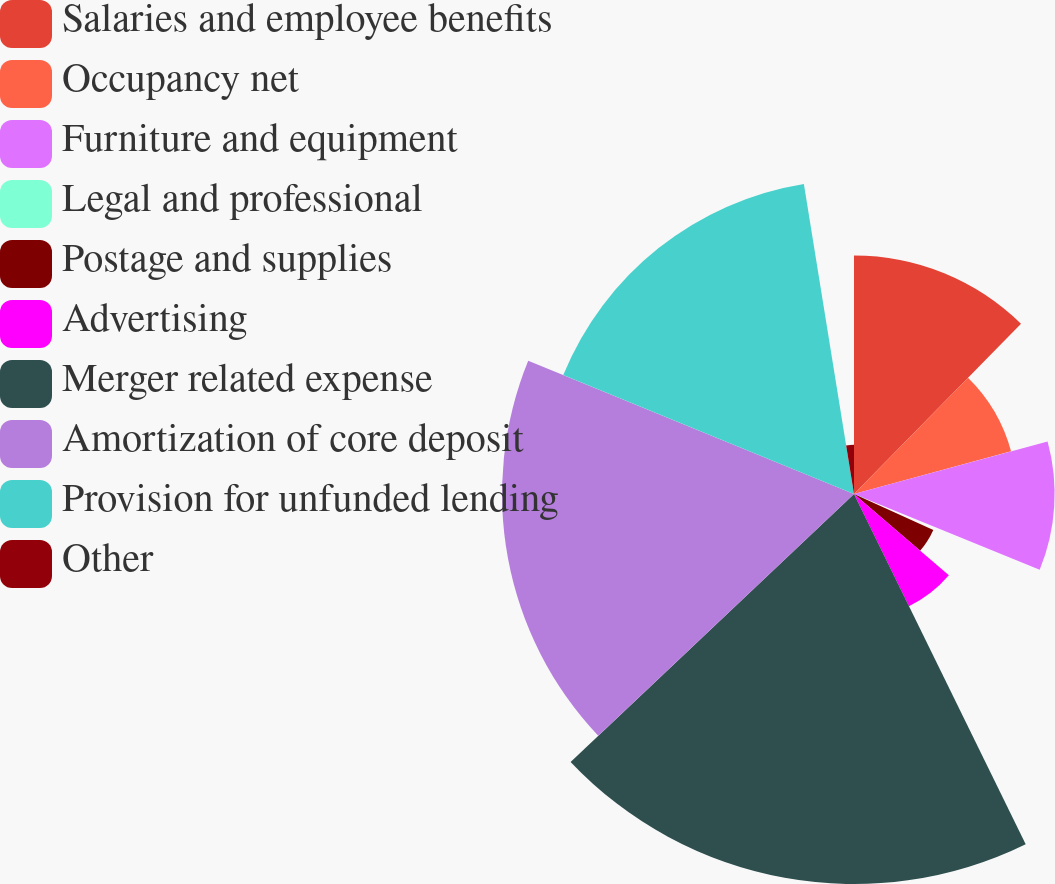Convert chart. <chart><loc_0><loc_0><loc_500><loc_500><pie_chart><fcel>Salaries and employee benefits<fcel>Occupancy net<fcel>Furniture and equipment<fcel>Legal and professional<fcel>Postage and supplies<fcel>Advertising<fcel>Merger related expense<fcel>Amortization of core deposit<fcel>Provision for unfunded lending<fcel>Other<nl><fcel>12.35%<fcel>8.43%<fcel>10.39%<fcel>0.59%<fcel>4.51%<fcel>6.47%<fcel>20.2%<fcel>18.23%<fcel>16.27%<fcel>2.55%<nl></chart> 